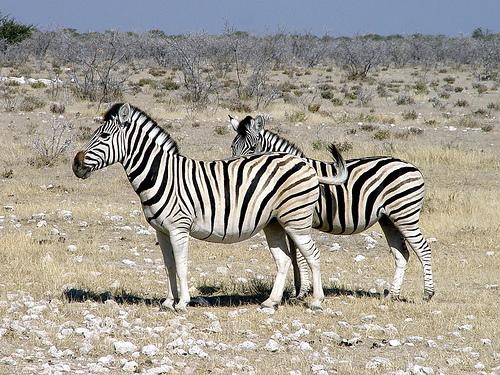What color is the zebra's mane and what unique feature does it have? The zebra's mane is black and white, and it runs from the forehead down the back of the neck. State one detail about the zebra's tail. The tail is wagging and has a black tip. Can you identify any specific markings on the zebra's legs? There are faded black stripes on one of the zebra's legs. How would you describe the condition of the grass in the image? The grass appears to be dead and patchy brown in color. What are the primary animals seen throughout the image? Two zebras standing on the plains. Can you find a plant that stands out from its surroundings in the image? There is a lone green plant behind the zebras. Describe the condition of the trees in the background. There are bare trees growing in the background, surrounded by dead shrubbery. What color are the rocks on the ground? The rocks on the ground are white. Briefly describe the landscape in which the zebras are found. The zebras are standing on a rocky plain with patchy brown grass and dead shrubbery in the background. Count and describe the legs of the zebras. There are four visible legs – two front legs and two back legs – with faded black stripes. Try to locate a group of red birds perching on the bare trees in the background. The birds are really vibrant and easy to spot. No, it's not mentioned in the image. 